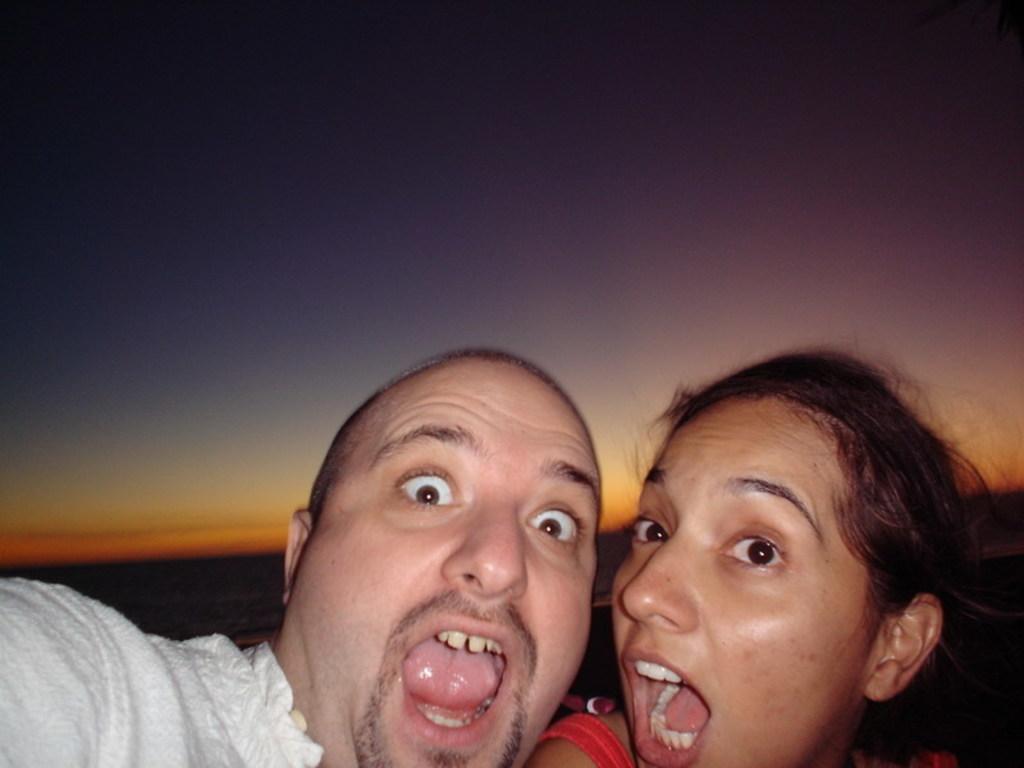Please provide a concise description of this image. In this image, we can see a man and woman are open their mouth. Background we can see the sky. 